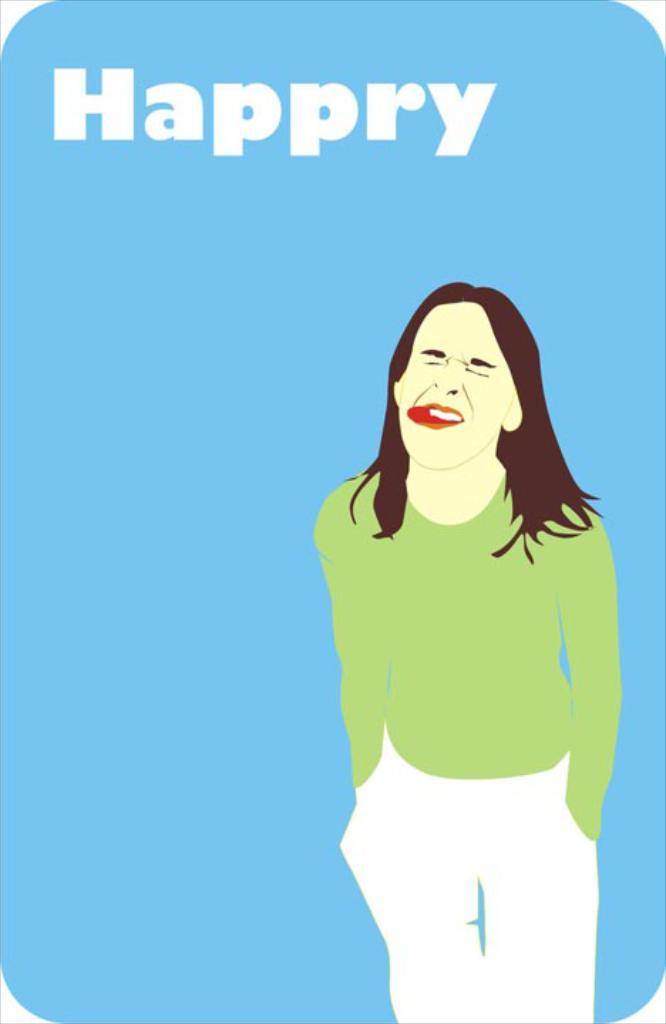<image>
Describe the image concisely. The woman has her tongue stuck out and the misspelling of happy is on the photo. 